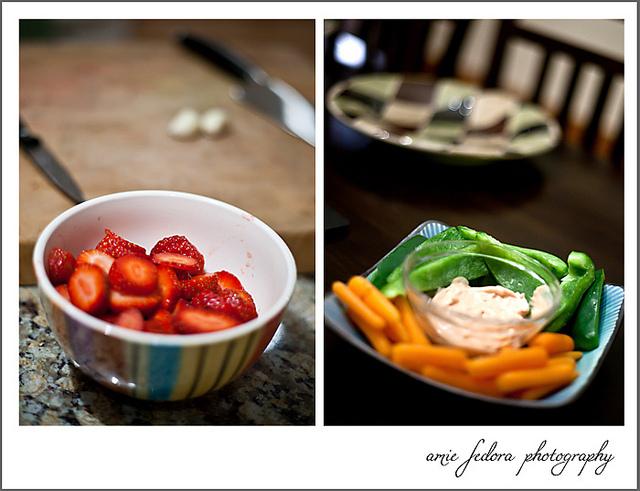What is the fruit in?
Short answer required. Bowl. Can you see a knife?
Write a very short answer. Yes. What type of fruit is being shown on the left?
Answer briefly. Strawberries. 